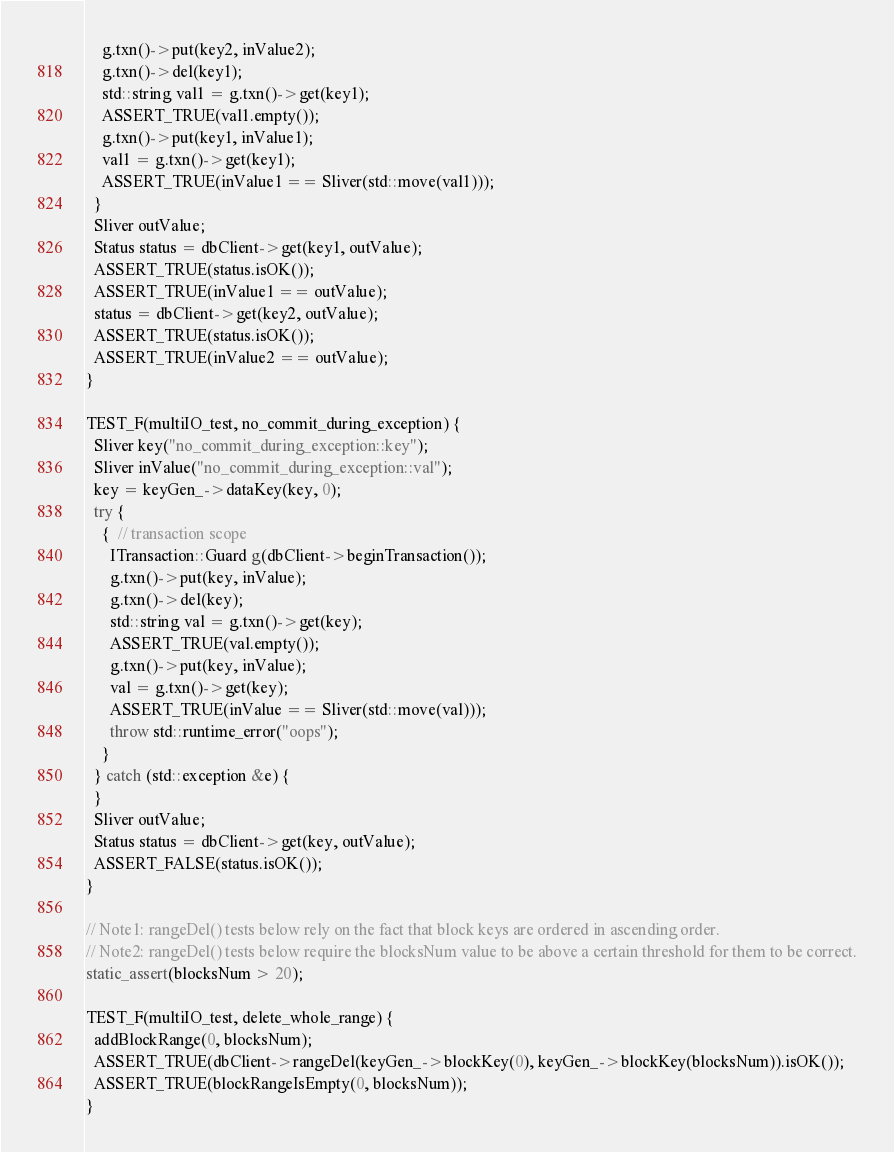<code> <loc_0><loc_0><loc_500><loc_500><_C++_>    g.txn()->put(key2, inValue2);
    g.txn()->del(key1);
    std::string val1 = g.txn()->get(key1);
    ASSERT_TRUE(val1.empty());
    g.txn()->put(key1, inValue1);
    val1 = g.txn()->get(key1);
    ASSERT_TRUE(inValue1 == Sliver(std::move(val1)));
  }
  Sliver outValue;
  Status status = dbClient->get(key1, outValue);
  ASSERT_TRUE(status.isOK());
  ASSERT_TRUE(inValue1 == outValue);
  status = dbClient->get(key2, outValue);
  ASSERT_TRUE(status.isOK());
  ASSERT_TRUE(inValue2 == outValue);
}

TEST_F(multiIO_test, no_commit_during_exception) {
  Sliver key("no_commit_during_exception::key");
  Sliver inValue("no_commit_during_exception::val");
  key = keyGen_->dataKey(key, 0);
  try {
    {  // transaction scope
      ITransaction::Guard g(dbClient->beginTransaction());
      g.txn()->put(key, inValue);
      g.txn()->del(key);
      std::string val = g.txn()->get(key);
      ASSERT_TRUE(val.empty());
      g.txn()->put(key, inValue);
      val = g.txn()->get(key);
      ASSERT_TRUE(inValue == Sliver(std::move(val)));
      throw std::runtime_error("oops");
    }
  } catch (std::exception &e) {
  }
  Sliver outValue;
  Status status = dbClient->get(key, outValue);
  ASSERT_FALSE(status.isOK());
}

// Note1: rangeDel() tests below rely on the fact that block keys are ordered in ascending order.
// Note2: rangeDel() tests below require the blocksNum value to be above a certain threshold for them to be correct.
static_assert(blocksNum > 20);

TEST_F(multiIO_test, delete_whole_range) {
  addBlockRange(0, blocksNum);
  ASSERT_TRUE(dbClient->rangeDel(keyGen_->blockKey(0), keyGen_->blockKey(blocksNum)).isOK());
  ASSERT_TRUE(blockRangeIsEmpty(0, blocksNum));
}
</code> 